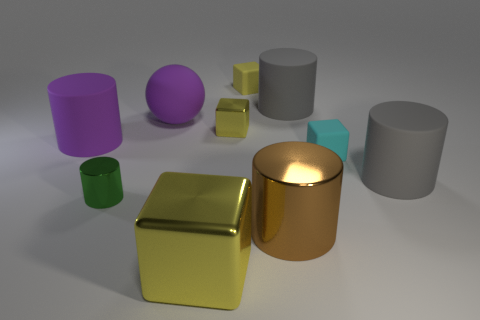Subtract all yellow cylinders. How many yellow blocks are left? 3 Subtract all large purple matte cylinders. How many cylinders are left? 4 Subtract all green cylinders. How many cylinders are left? 4 Subtract 1 blocks. How many blocks are left? 3 Subtract all blue blocks. Subtract all purple cylinders. How many blocks are left? 4 Subtract all balls. How many objects are left? 9 Subtract all brown shiny cylinders. Subtract all big gray matte cylinders. How many objects are left? 7 Add 6 metal cubes. How many metal cubes are left? 8 Add 8 purple shiny things. How many purple shiny things exist? 8 Subtract 0 red balls. How many objects are left? 10 